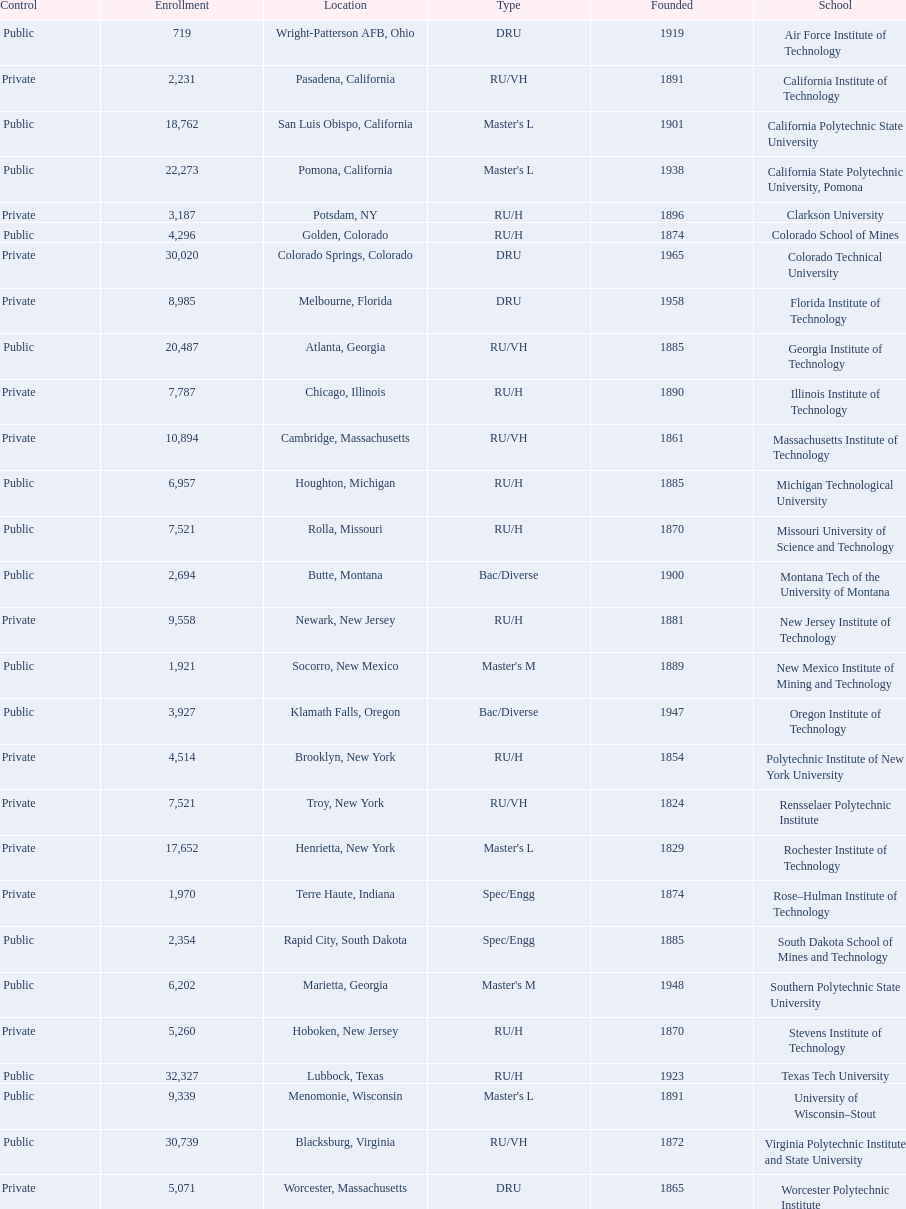Which of the educational institutions was established initially? Rensselaer Polytechnic Institute. I'm looking to parse the entire table for insights. Could you assist me with that? {'header': ['Control', 'Enrollment', 'Location', 'Type', 'Founded', 'School'], 'rows': [['Public', '719', 'Wright-Patterson AFB, Ohio', 'DRU', '1919', 'Air Force Institute of Technology'], ['Private', '2,231', 'Pasadena, California', 'RU/VH', '1891', 'California Institute of Technology'], ['Public', '18,762', 'San Luis Obispo, California', "Master's L", '1901', 'California Polytechnic State University'], ['Public', '22,273', 'Pomona, California', "Master's L", '1938', 'California State Polytechnic University, Pomona'], ['Private', '3,187', 'Potsdam, NY', 'RU/H', '1896', 'Clarkson University'], ['Public', '4,296', 'Golden, Colorado', 'RU/H', '1874', 'Colorado School of Mines'], ['Private', '30,020', 'Colorado Springs, Colorado', 'DRU', '1965', 'Colorado Technical University'], ['Private', '8,985', 'Melbourne, Florida', 'DRU', '1958', 'Florida Institute of Technology'], ['Public', '20,487', 'Atlanta, Georgia', 'RU/VH', '1885', 'Georgia Institute of Technology'], ['Private', '7,787', 'Chicago, Illinois', 'RU/H', '1890', 'Illinois Institute of Technology'], ['Private', '10,894', 'Cambridge, Massachusetts', 'RU/VH', '1861', 'Massachusetts Institute of Technology'], ['Public', '6,957', 'Houghton, Michigan', 'RU/H', '1885', 'Michigan Technological University'], ['Public', '7,521', 'Rolla, Missouri', 'RU/H', '1870', 'Missouri University of Science and Technology'], ['Public', '2,694', 'Butte, Montana', 'Bac/Diverse', '1900', 'Montana Tech of the University of Montana'], ['Private', '9,558', 'Newark, New Jersey', 'RU/H', '1881', 'New Jersey Institute of Technology'], ['Public', '1,921', 'Socorro, New Mexico', "Master's M", '1889', 'New Mexico Institute of Mining and Technology'], ['Public', '3,927', 'Klamath Falls, Oregon', 'Bac/Diverse', '1947', 'Oregon Institute of Technology'], ['Private', '4,514', 'Brooklyn, New York', 'RU/H', '1854', 'Polytechnic Institute of New York University'], ['Private', '7,521', 'Troy, New York', 'RU/VH', '1824', 'Rensselaer Polytechnic Institute'], ['Private', '17,652', 'Henrietta, New York', "Master's L", '1829', 'Rochester Institute of Technology'], ['Private', '1,970', 'Terre Haute, Indiana', 'Spec/Engg', '1874', 'Rose–Hulman Institute of Technology'], ['Public', '2,354', 'Rapid City, South Dakota', 'Spec/Engg', '1885', 'South Dakota School of Mines and Technology'], ['Public', '6,202', 'Marietta, Georgia', "Master's M", '1948', 'Southern Polytechnic State University'], ['Private', '5,260', 'Hoboken, New Jersey', 'RU/H', '1870', 'Stevens Institute of Technology'], ['Public', '32,327', 'Lubbock, Texas', 'RU/H', '1923', 'Texas Tech University'], ['Public', '9,339', 'Menomonie, Wisconsin', "Master's L", '1891', 'University of Wisconsin–Stout'], ['Public', '30,739', 'Blacksburg, Virginia', 'RU/VH', '1872', 'Virginia Polytechnic Institute and State University'], ['Private', '5,071', 'Worcester, Massachusetts', 'DRU', '1865', 'Worcester Polytechnic Institute']]} 